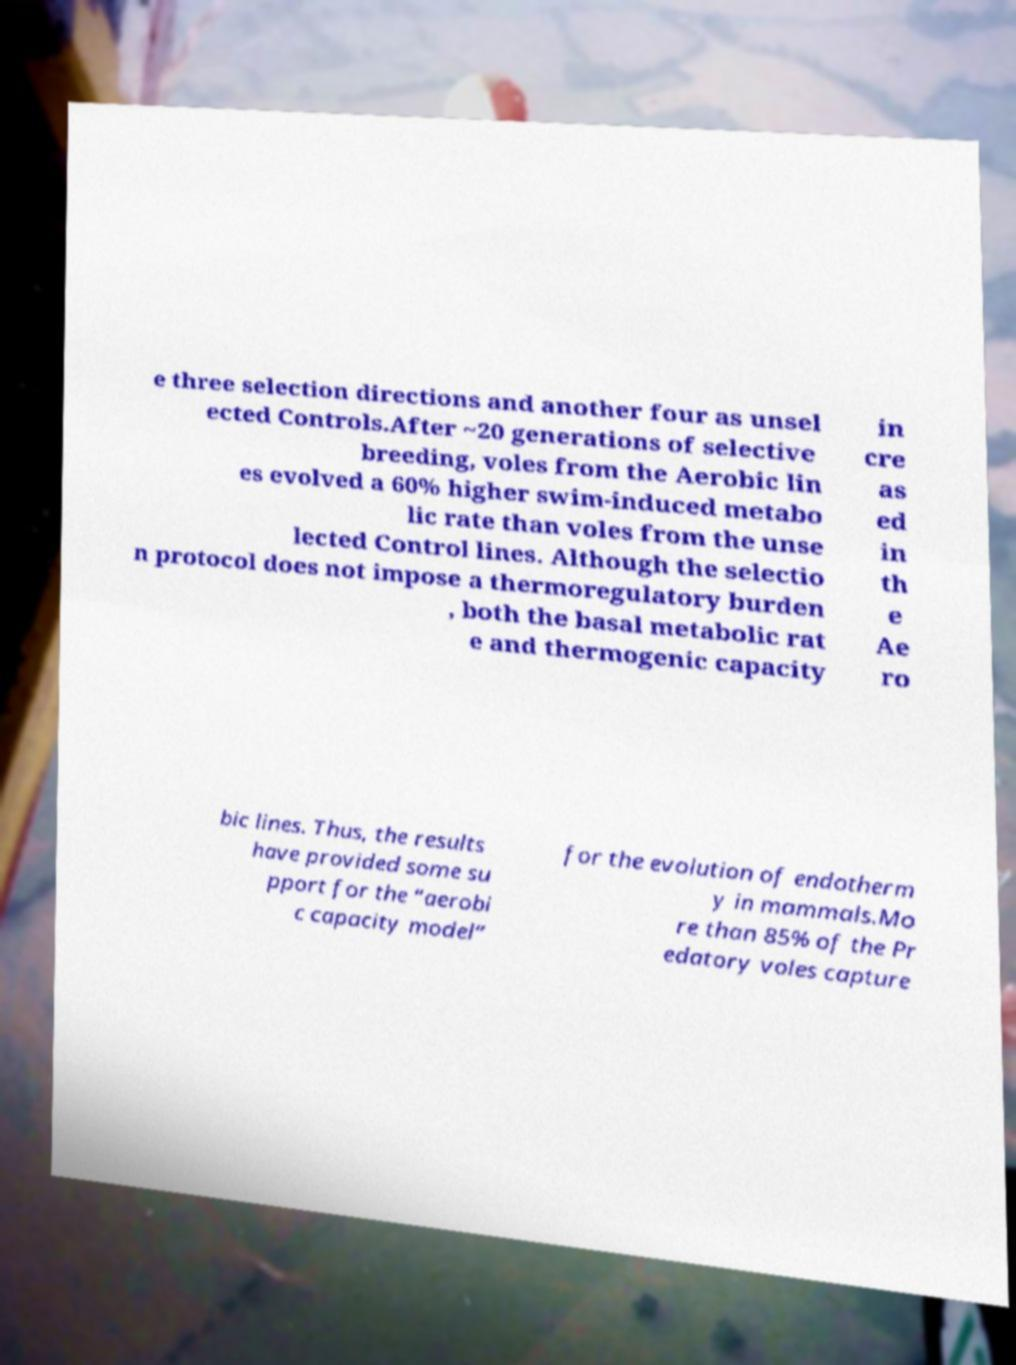I need the written content from this picture converted into text. Can you do that? e three selection directions and another four as unsel ected Controls.After ~20 generations of selective breeding, voles from the Aerobic lin es evolved a 60% higher swim-induced metabo lic rate than voles from the unse lected Control lines. Although the selectio n protocol does not impose a thermoregulatory burden , both the basal metabolic rat e and thermogenic capacity in cre as ed in th e Ae ro bic lines. Thus, the results have provided some su pport for the “aerobi c capacity model” for the evolution of endotherm y in mammals.Mo re than 85% of the Pr edatory voles capture 